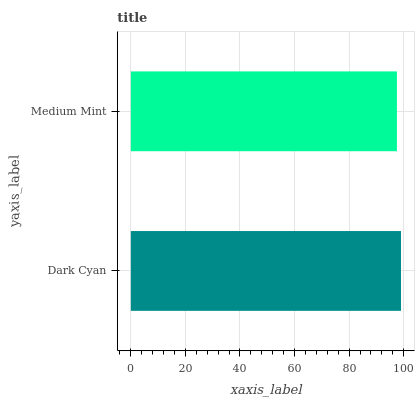Is Medium Mint the minimum?
Answer yes or no. Yes. Is Dark Cyan the maximum?
Answer yes or no. Yes. Is Medium Mint the maximum?
Answer yes or no. No. Is Dark Cyan greater than Medium Mint?
Answer yes or no. Yes. Is Medium Mint less than Dark Cyan?
Answer yes or no. Yes. Is Medium Mint greater than Dark Cyan?
Answer yes or no. No. Is Dark Cyan less than Medium Mint?
Answer yes or no. No. Is Dark Cyan the high median?
Answer yes or no. Yes. Is Medium Mint the low median?
Answer yes or no. Yes. Is Medium Mint the high median?
Answer yes or no. No. Is Dark Cyan the low median?
Answer yes or no. No. 